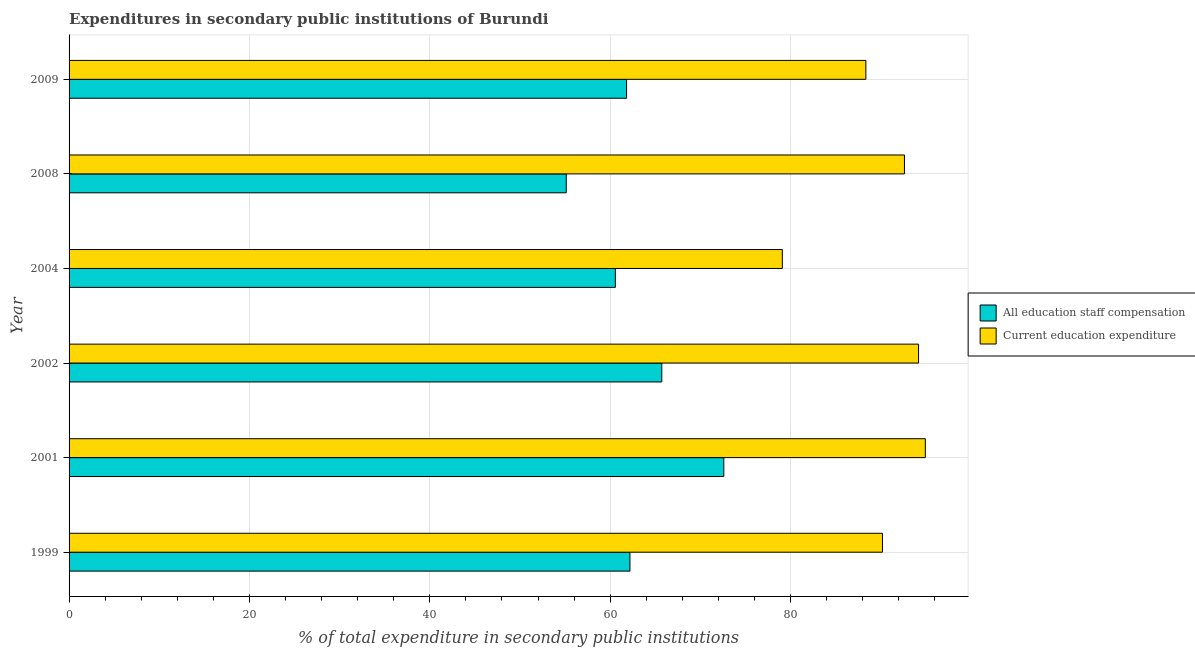What is the expenditure in education in 2008?
Keep it short and to the point. 92.63. Across all years, what is the maximum expenditure in education?
Provide a succinct answer. 94.95. Across all years, what is the minimum expenditure in staff compensation?
Provide a short and direct response. 55.13. In which year was the expenditure in staff compensation maximum?
Your response must be concise. 2001. What is the total expenditure in staff compensation in the graph?
Provide a short and direct response. 378.03. What is the difference between the expenditure in education in 1999 and that in 2008?
Offer a very short reply. -2.44. What is the difference between the expenditure in education in 2009 and the expenditure in staff compensation in 2002?
Your response must be concise. 22.63. What is the average expenditure in staff compensation per year?
Your answer should be very brief. 63.01. In the year 2009, what is the difference between the expenditure in education and expenditure in staff compensation?
Your answer should be very brief. 26.53. In how many years, is the expenditure in staff compensation greater than 44 %?
Offer a very short reply. 6. What is the ratio of the expenditure in staff compensation in 1999 to that in 2009?
Your answer should be compact. 1.01. Is the difference between the expenditure in staff compensation in 2002 and 2004 greater than the difference between the expenditure in education in 2002 and 2004?
Offer a very short reply. No. What is the difference between the highest and the second highest expenditure in staff compensation?
Provide a short and direct response. 6.88. What is the difference between the highest and the lowest expenditure in education?
Provide a succinct answer. 15.86. Is the sum of the expenditure in staff compensation in 1999 and 2008 greater than the maximum expenditure in education across all years?
Make the answer very short. Yes. What does the 2nd bar from the top in 2009 represents?
Your response must be concise. All education staff compensation. What does the 1st bar from the bottom in 1999 represents?
Give a very brief answer. All education staff compensation. Are all the bars in the graph horizontal?
Your answer should be compact. Yes. How many years are there in the graph?
Make the answer very short. 6. What is the difference between two consecutive major ticks on the X-axis?
Offer a very short reply. 20. Are the values on the major ticks of X-axis written in scientific E-notation?
Ensure brevity in your answer.  No. Does the graph contain grids?
Make the answer very short. Yes. Where does the legend appear in the graph?
Your response must be concise. Center right. How many legend labels are there?
Offer a terse response. 2. How are the legend labels stacked?
Keep it short and to the point. Vertical. What is the title of the graph?
Keep it short and to the point. Expenditures in secondary public institutions of Burundi. What is the label or title of the X-axis?
Your answer should be compact. % of total expenditure in secondary public institutions. What is the label or title of the Y-axis?
Your answer should be compact. Year. What is the % of total expenditure in secondary public institutions of All education staff compensation in 1999?
Give a very brief answer. 62.19. What is the % of total expenditure in secondary public institutions in Current education expenditure in 1999?
Offer a very short reply. 90.19. What is the % of total expenditure in secondary public institutions in All education staff compensation in 2001?
Make the answer very short. 72.6. What is the % of total expenditure in secondary public institutions of Current education expenditure in 2001?
Keep it short and to the point. 94.95. What is the % of total expenditure in secondary public institutions in All education staff compensation in 2002?
Give a very brief answer. 65.72. What is the % of total expenditure in secondary public institutions in Current education expenditure in 2002?
Provide a succinct answer. 94.19. What is the % of total expenditure in secondary public institutions in All education staff compensation in 2004?
Offer a very short reply. 60.57. What is the % of total expenditure in secondary public institutions in Current education expenditure in 2004?
Your answer should be compact. 79.09. What is the % of total expenditure in secondary public institutions in All education staff compensation in 2008?
Provide a succinct answer. 55.13. What is the % of total expenditure in secondary public institutions in Current education expenditure in 2008?
Your answer should be very brief. 92.63. What is the % of total expenditure in secondary public institutions of All education staff compensation in 2009?
Offer a very short reply. 61.82. What is the % of total expenditure in secondary public institutions of Current education expenditure in 2009?
Offer a very short reply. 88.35. Across all years, what is the maximum % of total expenditure in secondary public institutions in All education staff compensation?
Your response must be concise. 72.6. Across all years, what is the maximum % of total expenditure in secondary public institutions of Current education expenditure?
Offer a terse response. 94.95. Across all years, what is the minimum % of total expenditure in secondary public institutions of All education staff compensation?
Your answer should be compact. 55.13. Across all years, what is the minimum % of total expenditure in secondary public institutions in Current education expenditure?
Give a very brief answer. 79.09. What is the total % of total expenditure in secondary public institutions in All education staff compensation in the graph?
Provide a succinct answer. 378.03. What is the total % of total expenditure in secondary public institutions in Current education expenditure in the graph?
Your answer should be compact. 539.4. What is the difference between the % of total expenditure in secondary public institutions in All education staff compensation in 1999 and that in 2001?
Offer a very short reply. -10.41. What is the difference between the % of total expenditure in secondary public institutions in Current education expenditure in 1999 and that in 2001?
Your answer should be compact. -4.75. What is the difference between the % of total expenditure in secondary public institutions of All education staff compensation in 1999 and that in 2002?
Keep it short and to the point. -3.53. What is the difference between the % of total expenditure in secondary public institutions of Current education expenditure in 1999 and that in 2002?
Your answer should be compact. -4. What is the difference between the % of total expenditure in secondary public institutions of All education staff compensation in 1999 and that in 2004?
Your answer should be very brief. 1.62. What is the difference between the % of total expenditure in secondary public institutions of Current education expenditure in 1999 and that in 2004?
Your answer should be very brief. 11.1. What is the difference between the % of total expenditure in secondary public institutions of All education staff compensation in 1999 and that in 2008?
Keep it short and to the point. 7.06. What is the difference between the % of total expenditure in secondary public institutions in Current education expenditure in 1999 and that in 2008?
Your answer should be very brief. -2.44. What is the difference between the % of total expenditure in secondary public institutions of All education staff compensation in 1999 and that in 2009?
Keep it short and to the point. 0.37. What is the difference between the % of total expenditure in secondary public institutions in Current education expenditure in 1999 and that in 2009?
Ensure brevity in your answer.  1.84. What is the difference between the % of total expenditure in secondary public institutions in All education staff compensation in 2001 and that in 2002?
Keep it short and to the point. 6.88. What is the difference between the % of total expenditure in secondary public institutions in Current education expenditure in 2001 and that in 2002?
Your answer should be compact. 0.75. What is the difference between the % of total expenditure in secondary public institutions of All education staff compensation in 2001 and that in 2004?
Your answer should be compact. 12.03. What is the difference between the % of total expenditure in secondary public institutions of Current education expenditure in 2001 and that in 2004?
Ensure brevity in your answer.  15.86. What is the difference between the % of total expenditure in secondary public institutions in All education staff compensation in 2001 and that in 2008?
Provide a succinct answer. 17.47. What is the difference between the % of total expenditure in secondary public institutions of Current education expenditure in 2001 and that in 2008?
Provide a short and direct response. 2.32. What is the difference between the % of total expenditure in secondary public institutions of All education staff compensation in 2001 and that in 2009?
Give a very brief answer. 10.78. What is the difference between the % of total expenditure in secondary public institutions in Current education expenditure in 2001 and that in 2009?
Provide a short and direct response. 6.59. What is the difference between the % of total expenditure in secondary public institutions of All education staff compensation in 2002 and that in 2004?
Provide a short and direct response. 5.15. What is the difference between the % of total expenditure in secondary public institutions in Current education expenditure in 2002 and that in 2004?
Give a very brief answer. 15.11. What is the difference between the % of total expenditure in secondary public institutions in All education staff compensation in 2002 and that in 2008?
Provide a short and direct response. 10.59. What is the difference between the % of total expenditure in secondary public institutions in Current education expenditure in 2002 and that in 2008?
Your response must be concise. 1.56. What is the difference between the % of total expenditure in secondary public institutions in All education staff compensation in 2002 and that in 2009?
Provide a short and direct response. 3.9. What is the difference between the % of total expenditure in secondary public institutions of Current education expenditure in 2002 and that in 2009?
Give a very brief answer. 5.84. What is the difference between the % of total expenditure in secondary public institutions of All education staff compensation in 2004 and that in 2008?
Your response must be concise. 5.44. What is the difference between the % of total expenditure in secondary public institutions of Current education expenditure in 2004 and that in 2008?
Your response must be concise. -13.54. What is the difference between the % of total expenditure in secondary public institutions in All education staff compensation in 2004 and that in 2009?
Your answer should be very brief. -1.24. What is the difference between the % of total expenditure in secondary public institutions of Current education expenditure in 2004 and that in 2009?
Your answer should be very brief. -9.26. What is the difference between the % of total expenditure in secondary public institutions in All education staff compensation in 2008 and that in 2009?
Make the answer very short. -6.69. What is the difference between the % of total expenditure in secondary public institutions of Current education expenditure in 2008 and that in 2009?
Ensure brevity in your answer.  4.28. What is the difference between the % of total expenditure in secondary public institutions of All education staff compensation in 1999 and the % of total expenditure in secondary public institutions of Current education expenditure in 2001?
Your response must be concise. -32.75. What is the difference between the % of total expenditure in secondary public institutions in All education staff compensation in 1999 and the % of total expenditure in secondary public institutions in Current education expenditure in 2002?
Keep it short and to the point. -32. What is the difference between the % of total expenditure in secondary public institutions in All education staff compensation in 1999 and the % of total expenditure in secondary public institutions in Current education expenditure in 2004?
Ensure brevity in your answer.  -16.9. What is the difference between the % of total expenditure in secondary public institutions in All education staff compensation in 1999 and the % of total expenditure in secondary public institutions in Current education expenditure in 2008?
Offer a terse response. -30.44. What is the difference between the % of total expenditure in secondary public institutions in All education staff compensation in 1999 and the % of total expenditure in secondary public institutions in Current education expenditure in 2009?
Offer a very short reply. -26.16. What is the difference between the % of total expenditure in secondary public institutions of All education staff compensation in 2001 and the % of total expenditure in secondary public institutions of Current education expenditure in 2002?
Provide a succinct answer. -21.59. What is the difference between the % of total expenditure in secondary public institutions of All education staff compensation in 2001 and the % of total expenditure in secondary public institutions of Current education expenditure in 2004?
Offer a very short reply. -6.49. What is the difference between the % of total expenditure in secondary public institutions in All education staff compensation in 2001 and the % of total expenditure in secondary public institutions in Current education expenditure in 2008?
Make the answer very short. -20.03. What is the difference between the % of total expenditure in secondary public institutions of All education staff compensation in 2001 and the % of total expenditure in secondary public institutions of Current education expenditure in 2009?
Your answer should be very brief. -15.75. What is the difference between the % of total expenditure in secondary public institutions of All education staff compensation in 2002 and the % of total expenditure in secondary public institutions of Current education expenditure in 2004?
Keep it short and to the point. -13.37. What is the difference between the % of total expenditure in secondary public institutions in All education staff compensation in 2002 and the % of total expenditure in secondary public institutions in Current education expenditure in 2008?
Offer a terse response. -26.91. What is the difference between the % of total expenditure in secondary public institutions of All education staff compensation in 2002 and the % of total expenditure in secondary public institutions of Current education expenditure in 2009?
Provide a succinct answer. -22.63. What is the difference between the % of total expenditure in secondary public institutions in All education staff compensation in 2004 and the % of total expenditure in secondary public institutions in Current education expenditure in 2008?
Your answer should be very brief. -32.06. What is the difference between the % of total expenditure in secondary public institutions of All education staff compensation in 2004 and the % of total expenditure in secondary public institutions of Current education expenditure in 2009?
Offer a very short reply. -27.78. What is the difference between the % of total expenditure in secondary public institutions of All education staff compensation in 2008 and the % of total expenditure in secondary public institutions of Current education expenditure in 2009?
Your answer should be compact. -33.22. What is the average % of total expenditure in secondary public institutions of All education staff compensation per year?
Offer a terse response. 63.01. What is the average % of total expenditure in secondary public institutions in Current education expenditure per year?
Keep it short and to the point. 89.9. In the year 1999, what is the difference between the % of total expenditure in secondary public institutions in All education staff compensation and % of total expenditure in secondary public institutions in Current education expenditure?
Offer a terse response. -28. In the year 2001, what is the difference between the % of total expenditure in secondary public institutions in All education staff compensation and % of total expenditure in secondary public institutions in Current education expenditure?
Provide a short and direct response. -22.35. In the year 2002, what is the difference between the % of total expenditure in secondary public institutions of All education staff compensation and % of total expenditure in secondary public institutions of Current education expenditure?
Your answer should be compact. -28.47. In the year 2004, what is the difference between the % of total expenditure in secondary public institutions in All education staff compensation and % of total expenditure in secondary public institutions in Current education expenditure?
Give a very brief answer. -18.52. In the year 2008, what is the difference between the % of total expenditure in secondary public institutions of All education staff compensation and % of total expenditure in secondary public institutions of Current education expenditure?
Offer a terse response. -37.5. In the year 2009, what is the difference between the % of total expenditure in secondary public institutions in All education staff compensation and % of total expenditure in secondary public institutions in Current education expenditure?
Keep it short and to the point. -26.53. What is the ratio of the % of total expenditure in secondary public institutions in All education staff compensation in 1999 to that in 2001?
Make the answer very short. 0.86. What is the ratio of the % of total expenditure in secondary public institutions of Current education expenditure in 1999 to that in 2001?
Provide a succinct answer. 0.95. What is the ratio of the % of total expenditure in secondary public institutions in All education staff compensation in 1999 to that in 2002?
Offer a very short reply. 0.95. What is the ratio of the % of total expenditure in secondary public institutions in Current education expenditure in 1999 to that in 2002?
Give a very brief answer. 0.96. What is the ratio of the % of total expenditure in secondary public institutions of All education staff compensation in 1999 to that in 2004?
Make the answer very short. 1.03. What is the ratio of the % of total expenditure in secondary public institutions in Current education expenditure in 1999 to that in 2004?
Offer a terse response. 1.14. What is the ratio of the % of total expenditure in secondary public institutions of All education staff compensation in 1999 to that in 2008?
Provide a succinct answer. 1.13. What is the ratio of the % of total expenditure in secondary public institutions in Current education expenditure in 1999 to that in 2008?
Make the answer very short. 0.97. What is the ratio of the % of total expenditure in secondary public institutions of All education staff compensation in 1999 to that in 2009?
Your response must be concise. 1.01. What is the ratio of the % of total expenditure in secondary public institutions of Current education expenditure in 1999 to that in 2009?
Make the answer very short. 1.02. What is the ratio of the % of total expenditure in secondary public institutions in All education staff compensation in 2001 to that in 2002?
Offer a terse response. 1.1. What is the ratio of the % of total expenditure in secondary public institutions of Current education expenditure in 2001 to that in 2002?
Your response must be concise. 1.01. What is the ratio of the % of total expenditure in secondary public institutions of All education staff compensation in 2001 to that in 2004?
Your answer should be very brief. 1.2. What is the ratio of the % of total expenditure in secondary public institutions in Current education expenditure in 2001 to that in 2004?
Provide a short and direct response. 1.2. What is the ratio of the % of total expenditure in secondary public institutions in All education staff compensation in 2001 to that in 2008?
Provide a succinct answer. 1.32. What is the ratio of the % of total expenditure in secondary public institutions of Current education expenditure in 2001 to that in 2008?
Your answer should be very brief. 1.02. What is the ratio of the % of total expenditure in secondary public institutions in All education staff compensation in 2001 to that in 2009?
Offer a very short reply. 1.17. What is the ratio of the % of total expenditure in secondary public institutions in Current education expenditure in 2001 to that in 2009?
Your answer should be compact. 1.07. What is the ratio of the % of total expenditure in secondary public institutions of All education staff compensation in 2002 to that in 2004?
Offer a terse response. 1.08. What is the ratio of the % of total expenditure in secondary public institutions in Current education expenditure in 2002 to that in 2004?
Make the answer very short. 1.19. What is the ratio of the % of total expenditure in secondary public institutions in All education staff compensation in 2002 to that in 2008?
Give a very brief answer. 1.19. What is the ratio of the % of total expenditure in secondary public institutions of Current education expenditure in 2002 to that in 2008?
Offer a very short reply. 1.02. What is the ratio of the % of total expenditure in secondary public institutions in All education staff compensation in 2002 to that in 2009?
Provide a succinct answer. 1.06. What is the ratio of the % of total expenditure in secondary public institutions of Current education expenditure in 2002 to that in 2009?
Your response must be concise. 1.07. What is the ratio of the % of total expenditure in secondary public institutions of All education staff compensation in 2004 to that in 2008?
Your response must be concise. 1.1. What is the ratio of the % of total expenditure in secondary public institutions of Current education expenditure in 2004 to that in 2008?
Offer a terse response. 0.85. What is the ratio of the % of total expenditure in secondary public institutions of All education staff compensation in 2004 to that in 2009?
Ensure brevity in your answer.  0.98. What is the ratio of the % of total expenditure in secondary public institutions of Current education expenditure in 2004 to that in 2009?
Keep it short and to the point. 0.9. What is the ratio of the % of total expenditure in secondary public institutions of All education staff compensation in 2008 to that in 2009?
Your response must be concise. 0.89. What is the ratio of the % of total expenditure in secondary public institutions in Current education expenditure in 2008 to that in 2009?
Your response must be concise. 1.05. What is the difference between the highest and the second highest % of total expenditure in secondary public institutions in All education staff compensation?
Give a very brief answer. 6.88. What is the difference between the highest and the second highest % of total expenditure in secondary public institutions in Current education expenditure?
Your answer should be compact. 0.75. What is the difference between the highest and the lowest % of total expenditure in secondary public institutions of All education staff compensation?
Keep it short and to the point. 17.47. What is the difference between the highest and the lowest % of total expenditure in secondary public institutions of Current education expenditure?
Your answer should be very brief. 15.86. 